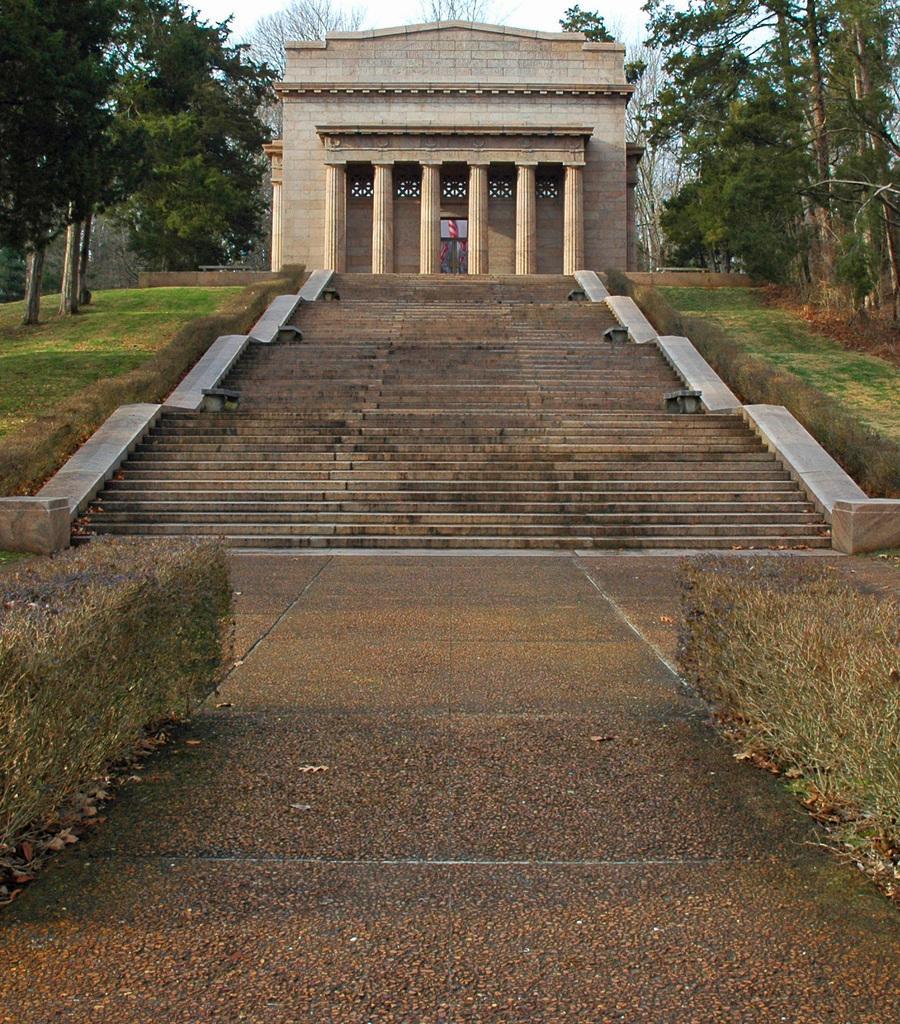How would you summarize this image in a sentence or two? In this picture, at the top right hand corner there are trees. At the left hand corner there are also trees and the middle it is the tree. 